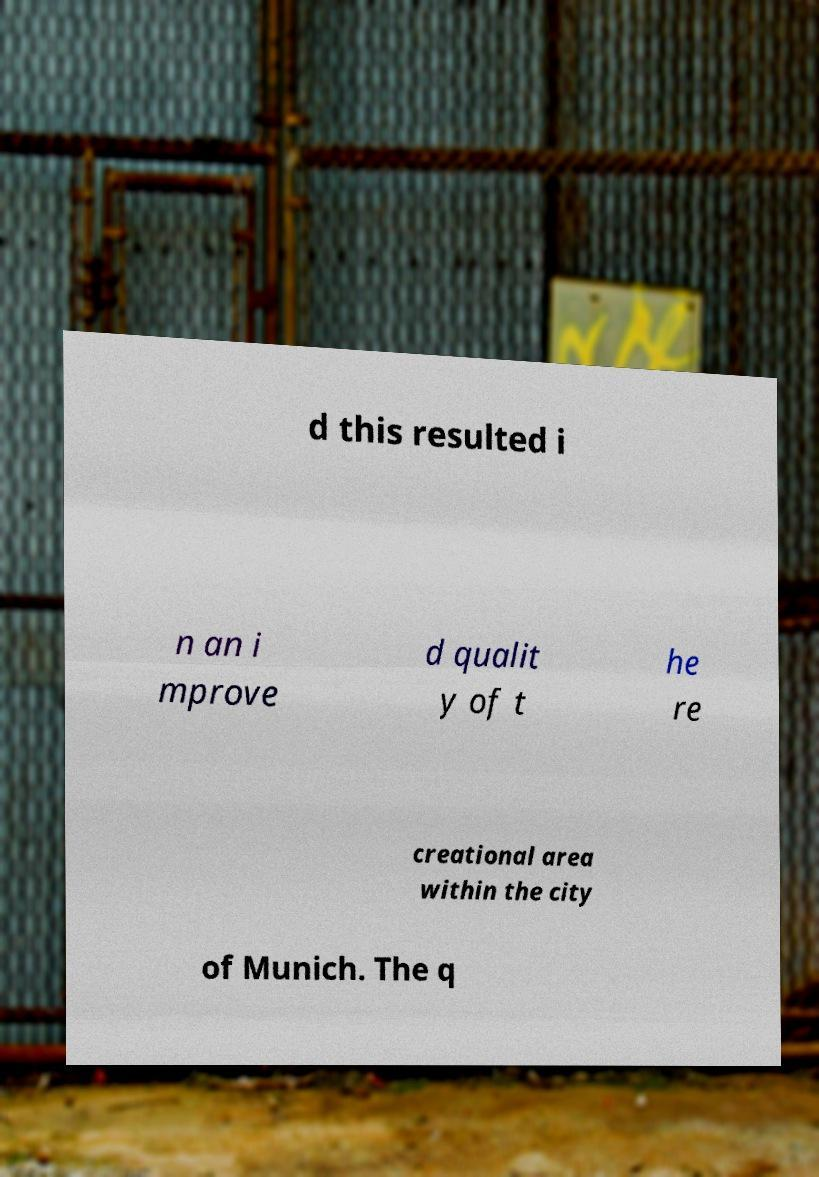There's text embedded in this image that I need extracted. Can you transcribe it verbatim? d this resulted i n an i mprove d qualit y of t he re creational area within the city of Munich. The q 